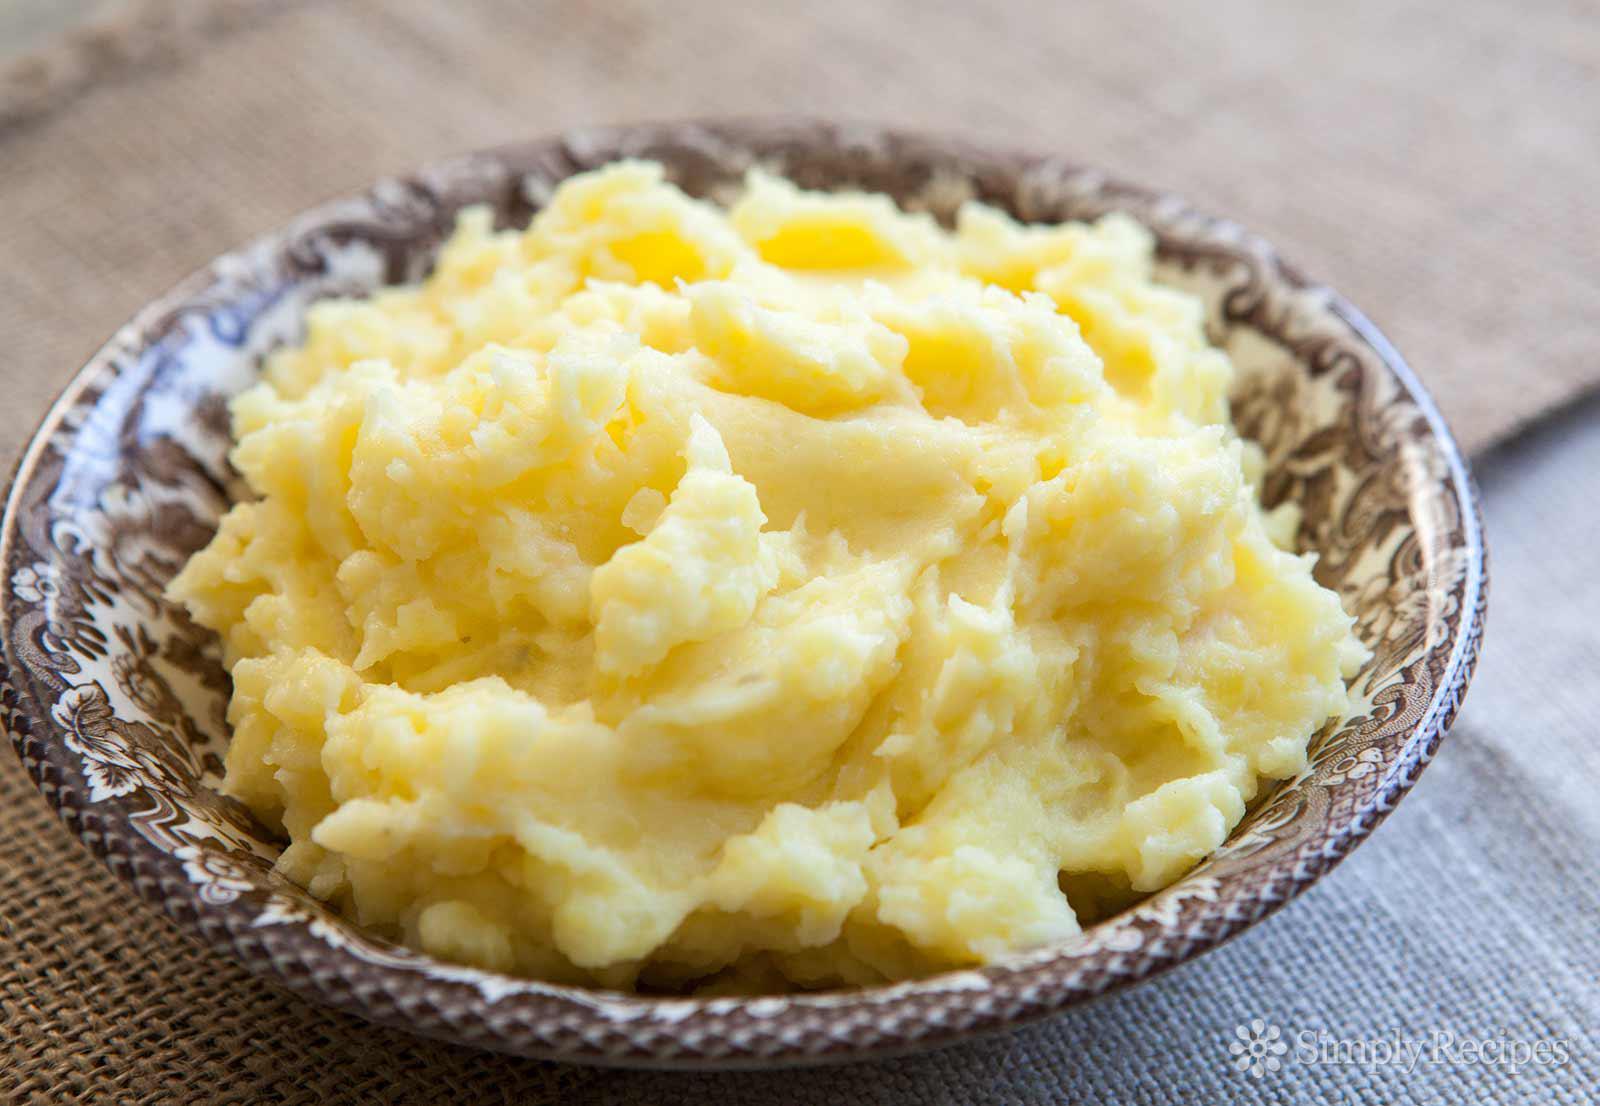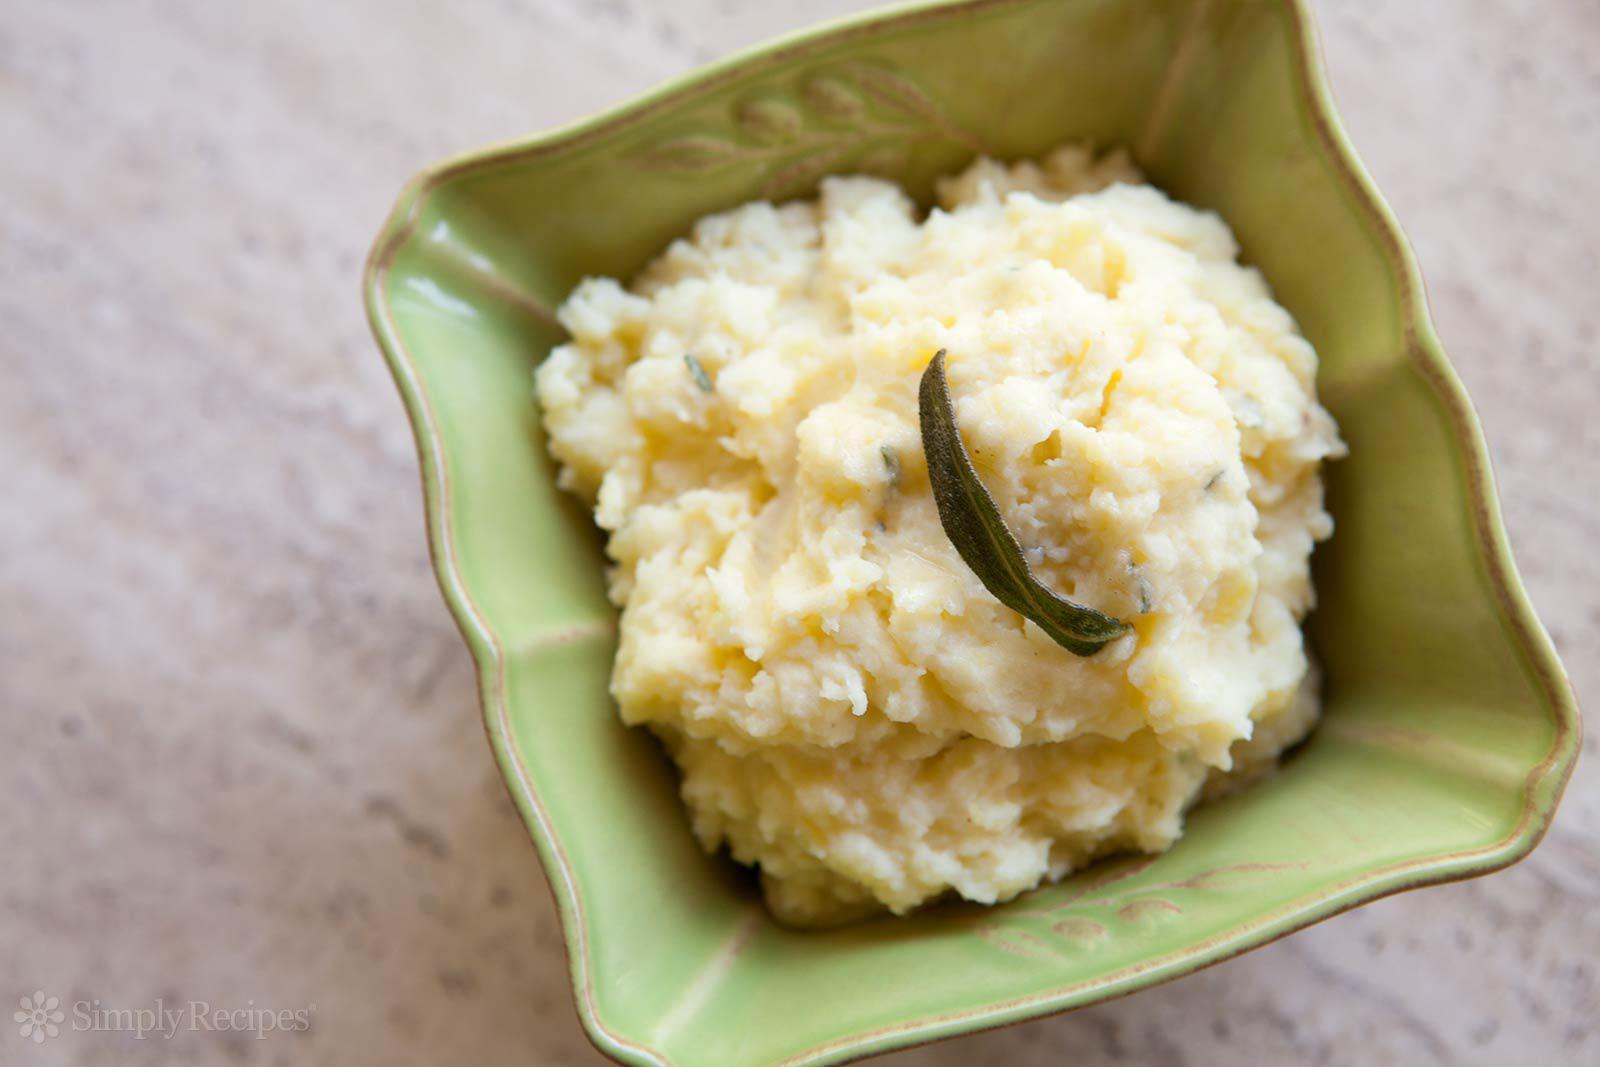The first image is the image on the left, the second image is the image on the right. Considering the images on both sides, is "One of the mashed potato dishes is squared, with four sides." valid? Answer yes or no. Yes. 